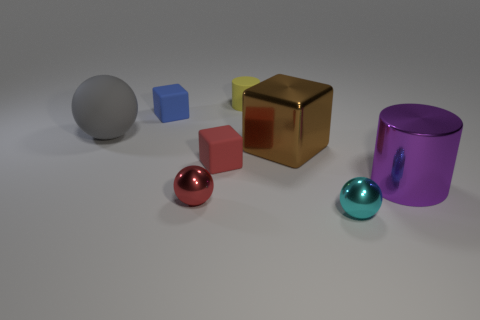Do the gray rubber thing and the rubber thing behind the tiny blue cube have the same shape?
Provide a short and direct response. No. What is the size of the blue object behind the small cube that is in front of the large gray object?
Offer a terse response. Small. Are there the same number of tiny blue blocks that are in front of the big brown metal cube and gray rubber spheres in front of the cyan metallic ball?
Offer a terse response. Yes. There is a large metal object that is the same shape as the small blue matte object; what color is it?
Offer a terse response. Brown. How many big cylinders are the same color as the big ball?
Make the answer very short. 0. Is the shape of the large brown thing behind the big purple cylinder the same as  the purple object?
Your answer should be compact. No. There is a rubber object in front of the gray matte thing that is in front of the cylinder that is on the left side of the metallic cylinder; what shape is it?
Provide a succinct answer. Cube. The shiny cylinder has what size?
Offer a terse response. Large. There is a cylinder that is made of the same material as the big gray object; what color is it?
Offer a terse response. Yellow. What number of other large gray balls have the same material as the gray ball?
Your answer should be compact. 0. 